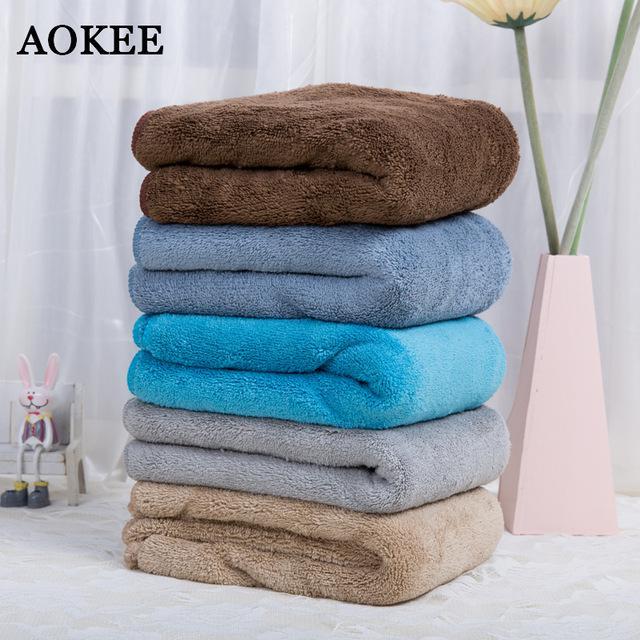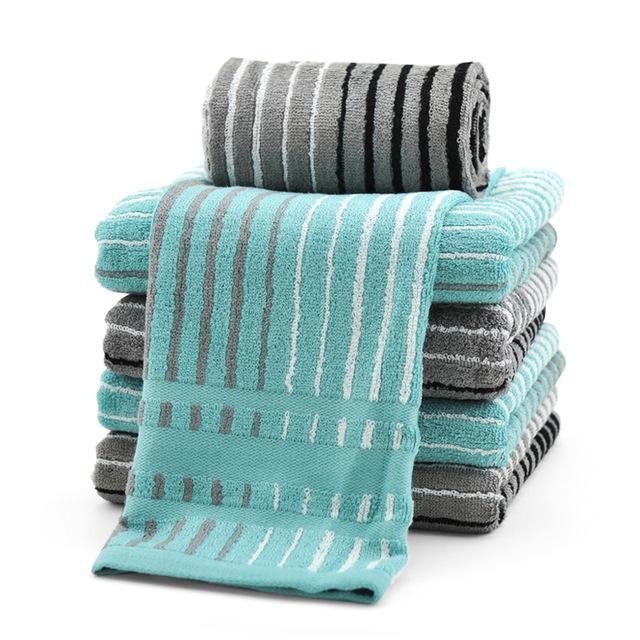The first image is the image on the left, the second image is the image on the right. For the images shown, is this caption "In one image, exactly five different colored towels, which are folded with edges to the inside, have been placed in a stack." true? Answer yes or no. Yes. The first image is the image on the left, the second image is the image on the right. For the images displayed, is the sentence "One image features exactly five folded towels in primarily blue and brown shades." factually correct? Answer yes or no. Yes. 